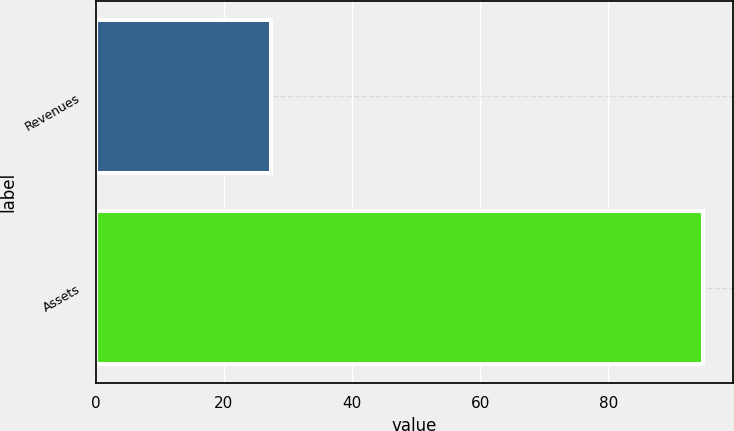<chart> <loc_0><loc_0><loc_500><loc_500><bar_chart><fcel>Revenues<fcel>Assets<nl><fcel>27.3<fcel>94.7<nl></chart> 